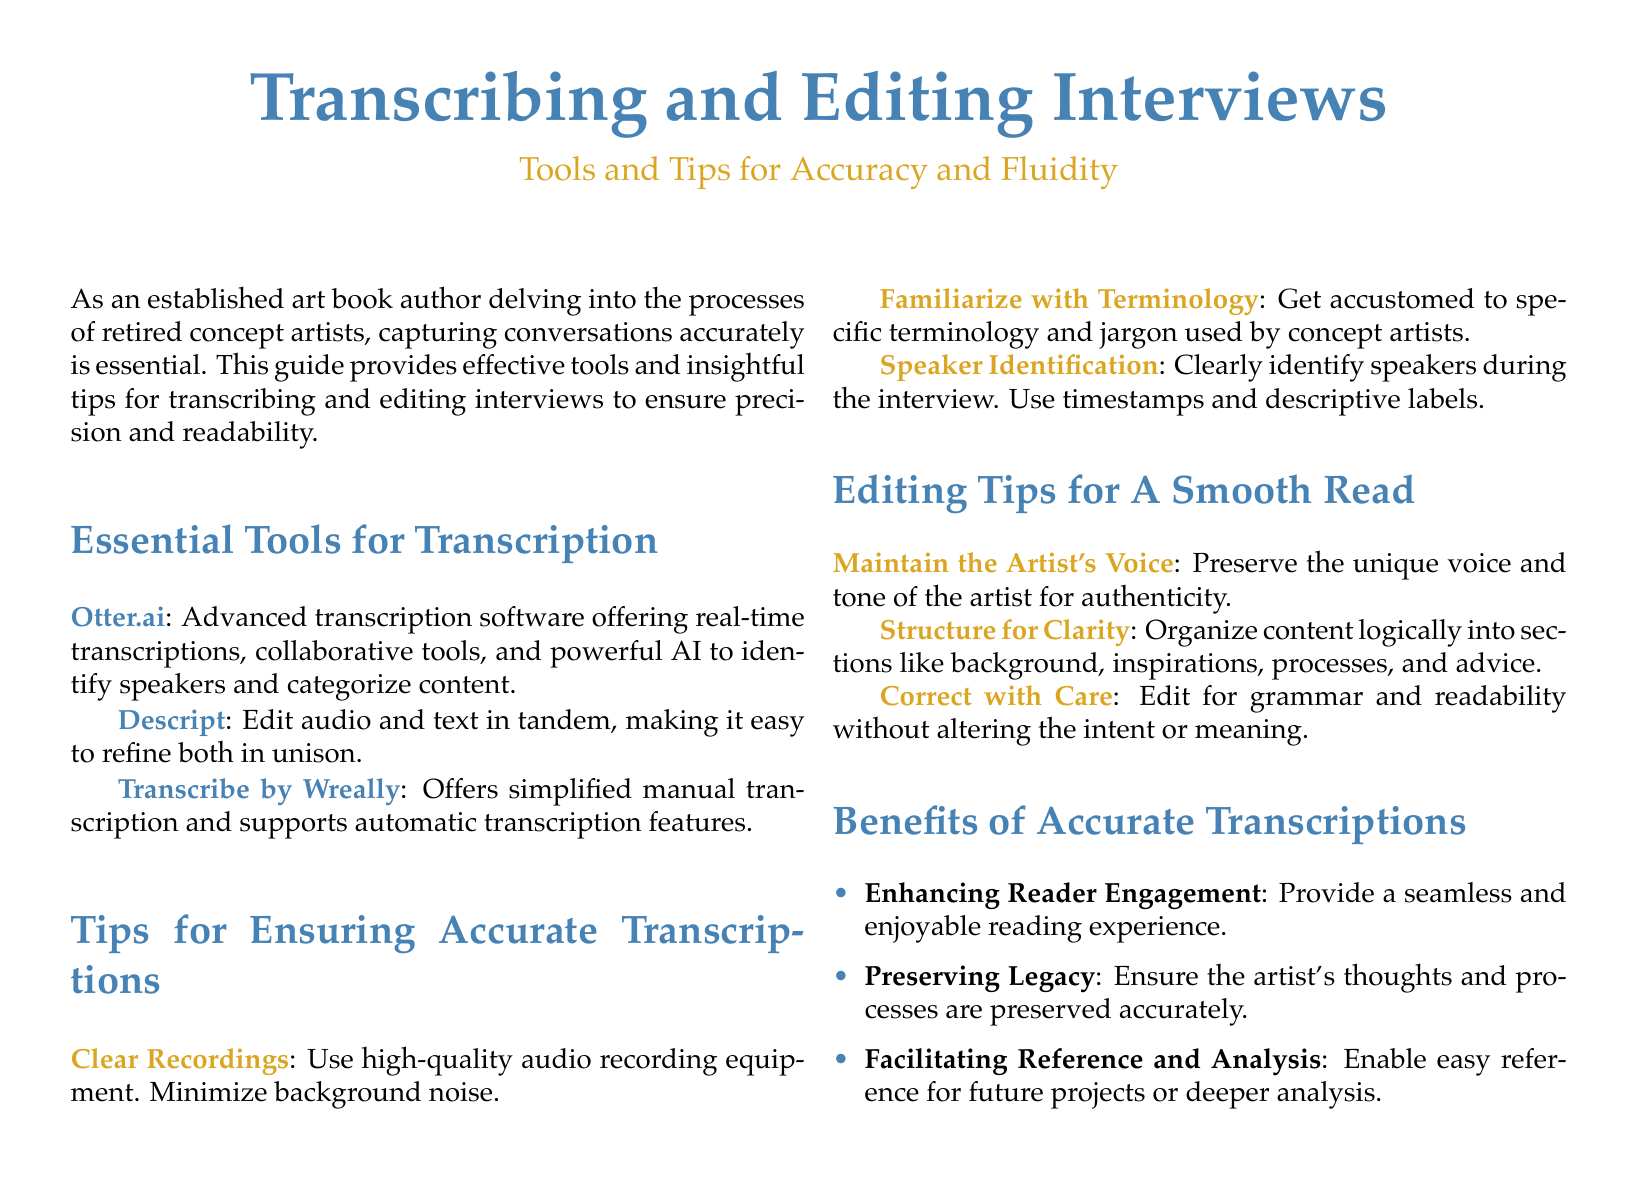What is the main focus of this guide? The guide focuses on tools and tips for transcribing and editing interviews for accuracy and fluidity.
Answer: Tools and tips for accuracy and fluidity What software is mentioned for real-time transcriptions? The software highlighted for real-time transcriptions is noted for its advanced features and collaborative tools.
Answer: Otter.ai What should you use to minimize background noise while recording? The document emphasizes high-quality audio recording equipment to ensure clarity during transcription.
Answer: High-quality audio recording equipment Which tool allows editing audio and text simultaneously? The guide specifies a tool that facilitates editing both audio and text in tandem for efficiency.
Answer: Descript What is one editing tip for maintaining authenticity? The guide suggests a specific approach to preserve the artist's unique expression during editing.
Answer: Preserve the unique voice and tone of the artist How many benefits of accurate transcriptions are listed? The number of benefits highlighted in the document indicates how accurate transcriptions enhance various aspects of the interview process.
Answer: Three What does the guide recommend for speaker identification during interviews? The document advises a method for clearly distinguishing between speakers to improve transcription accuracy.
Answer: Use timestamps and descriptive labels What is one purpose of accurate transcriptions mentioned? Among the benefits listed is a key reason why accurate transcriptions are essential for future endeavors or projects.
Answer: Facilitating reference and analysis 